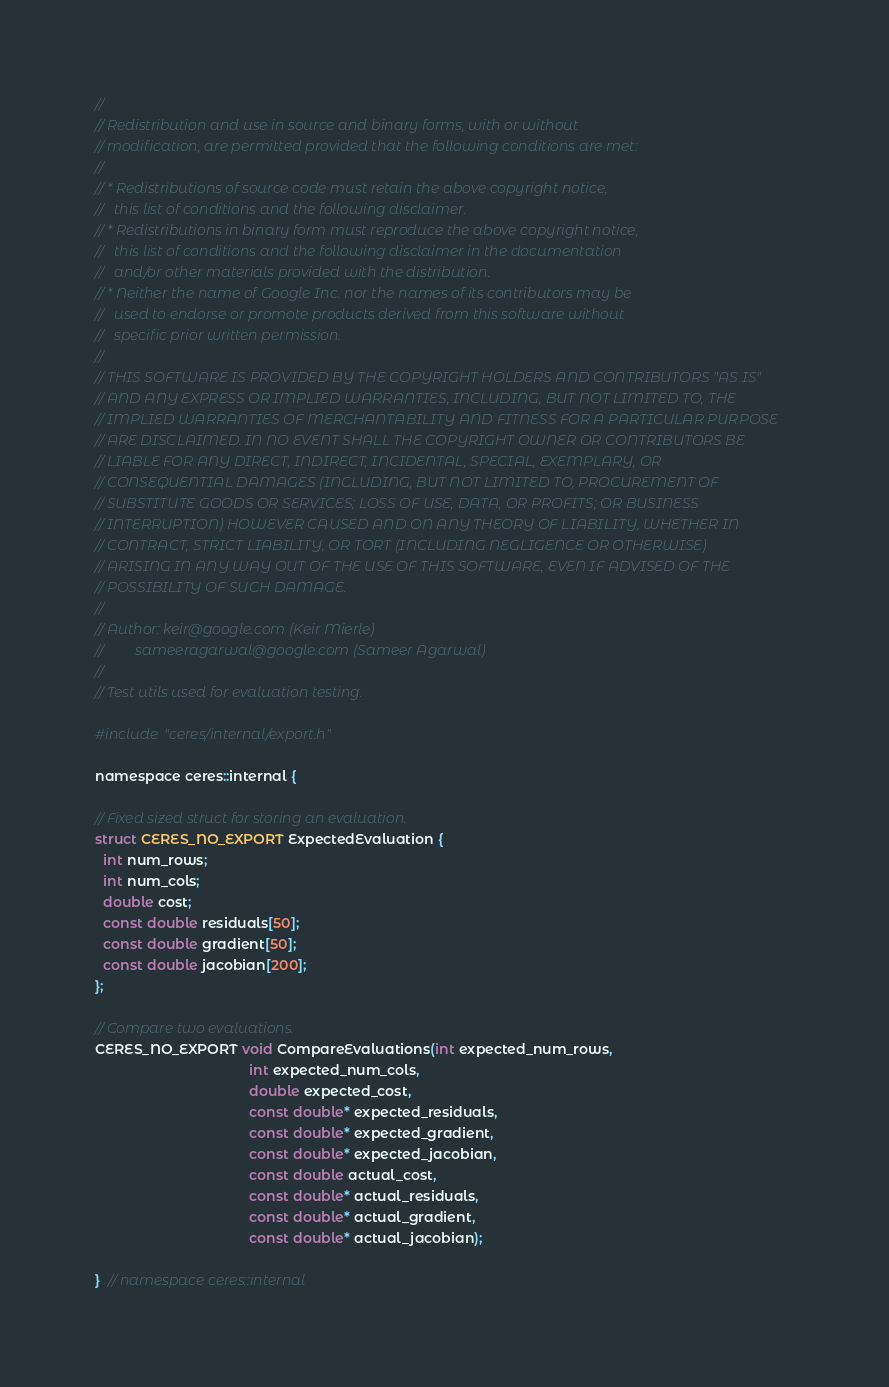Convert code to text. <code><loc_0><loc_0><loc_500><loc_500><_C_>//
// Redistribution and use in source and binary forms, with or without
// modification, are permitted provided that the following conditions are met:
//
// * Redistributions of source code must retain the above copyright notice,
//   this list of conditions and the following disclaimer.
// * Redistributions in binary form must reproduce the above copyright notice,
//   this list of conditions and the following disclaimer in the documentation
//   and/or other materials provided with the distribution.
// * Neither the name of Google Inc. nor the names of its contributors may be
//   used to endorse or promote products derived from this software without
//   specific prior written permission.
//
// THIS SOFTWARE IS PROVIDED BY THE COPYRIGHT HOLDERS AND CONTRIBUTORS "AS IS"
// AND ANY EXPRESS OR IMPLIED WARRANTIES, INCLUDING, BUT NOT LIMITED TO, THE
// IMPLIED WARRANTIES OF MERCHANTABILITY AND FITNESS FOR A PARTICULAR PURPOSE
// ARE DISCLAIMED. IN NO EVENT SHALL THE COPYRIGHT OWNER OR CONTRIBUTORS BE
// LIABLE FOR ANY DIRECT, INDIRECT, INCIDENTAL, SPECIAL, EXEMPLARY, OR
// CONSEQUENTIAL DAMAGES (INCLUDING, BUT NOT LIMITED TO, PROCUREMENT OF
// SUBSTITUTE GOODS OR SERVICES; LOSS OF USE, DATA, OR PROFITS; OR BUSINESS
// INTERRUPTION) HOWEVER CAUSED AND ON ANY THEORY OF LIABILITY, WHETHER IN
// CONTRACT, STRICT LIABILITY, OR TORT (INCLUDING NEGLIGENCE OR OTHERWISE)
// ARISING IN ANY WAY OUT OF THE USE OF THIS SOFTWARE, EVEN IF ADVISED OF THE
// POSSIBILITY OF SUCH DAMAGE.
//
// Author: keir@google.com (Keir Mierle)
//         sameeragarwal@google.com (Sameer Agarwal)
//
// Test utils used for evaluation testing.

#include "ceres/internal/export.h"

namespace ceres::internal {

// Fixed sized struct for storing an evaluation.
struct CERES_NO_EXPORT ExpectedEvaluation {
  int num_rows;
  int num_cols;
  double cost;
  const double residuals[50];
  const double gradient[50];
  const double jacobian[200];
};

// Compare two evaluations.
CERES_NO_EXPORT void CompareEvaluations(int expected_num_rows,
                                        int expected_num_cols,
                                        double expected_cost,
                                        const double* expected_residuals,
                                        const double* expected_gradient,
                                        const double* expected_jacobian,
                                        const double actual_cost,
                                        const double* actual_residuals,
                                        const double* actual_gradient,
                                        const double* actual_jacobian);

}  // namespace ceres::internal
</code> 